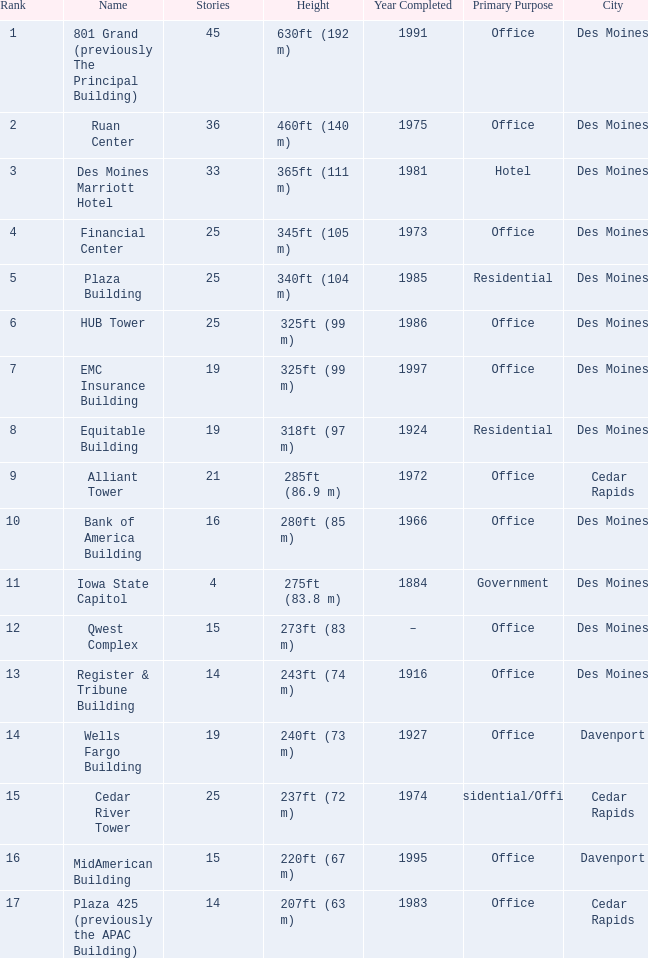What is the height of the EMC Insurance Building in Des Moines? 325ft (99 m). 